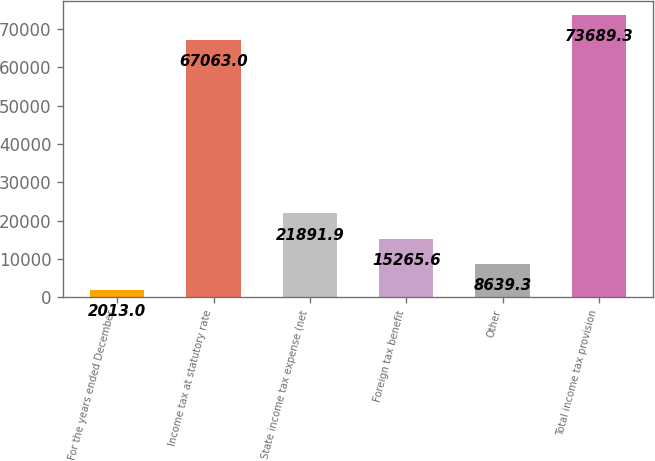Convert chart. <chart><loc_0><loc_0><loc_500><loc_500><bar_chart><fcel>For the years ended December<fcel>Income tax at statutory rate<fcel>State income tax expense (net<fcel>Foreign tax benefit<fcel>Other<fcel>Total income tax provision<nl><fcel>2013<fcel>67063<fcel>21891.9<fcel>15265.6<fcel>8639.3<fcel>73689.3<nl></chart> 